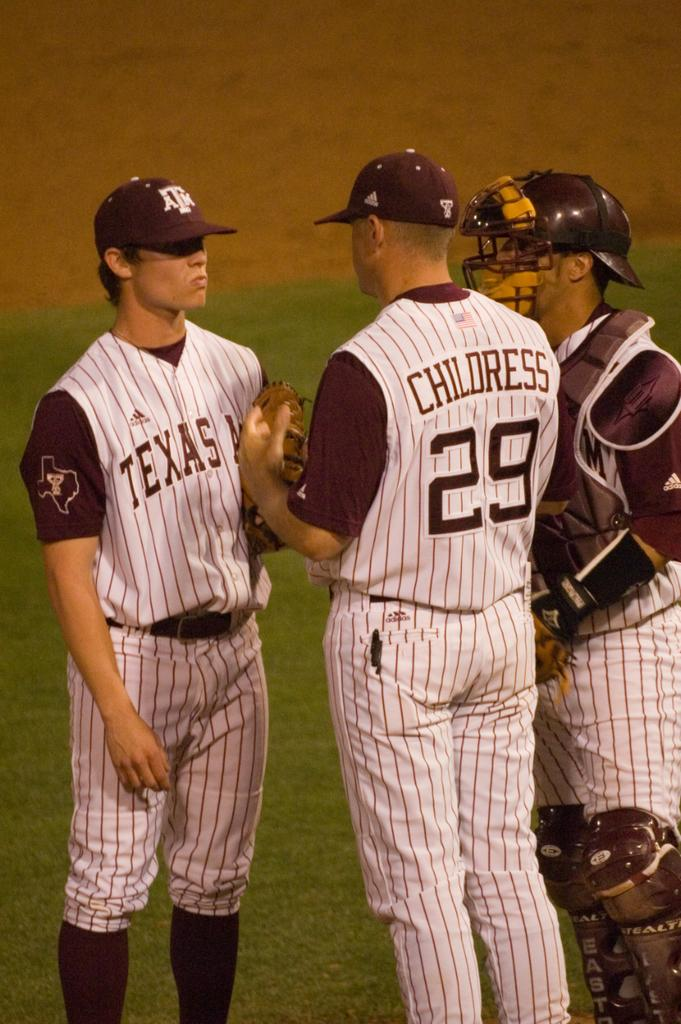<image>
Share a concise interpretation of the image provided. some baseball players with Texas jerseys talk in a field 